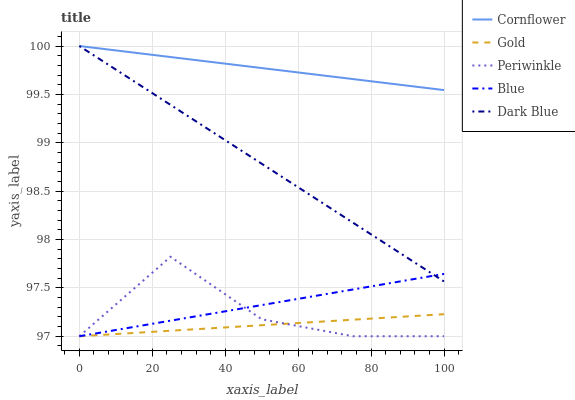Does Gold have the minimum area under the curve?
Answer yes or no. Yes. Does Cornflower have the maximum area under the curve?
Answer yes or no. Yes. Does Periwinkle have the minimum area under the curve?
Answer yes or no. No. Does Periwinkle have the maximum area under the curve?
Answer yes or no. No. Is Cornflower the smoothest?
Answer yes or no. Yes. Is Periwinkle the roughest?
Answer yes or no. Yes. Is Periwinkle the smoothest?
Answer yes or no. No. Is Cornflower the roughest?
Answer yes or no. No. Does Cornflower have the lowest value?
Answer yes or no. No. Does Dark Blue have the highest value?
Answer yes or no. Yes. Does Periwinkle have the highest value?
Answer yes or no. No. Is Gold less than Cornflower?
Answer yes or no. Yes. Is Dark Blue greater than Gold?
Answer yes or no. Yes. Does Gold intersect Cornflower?
Answer yes or no. No. 